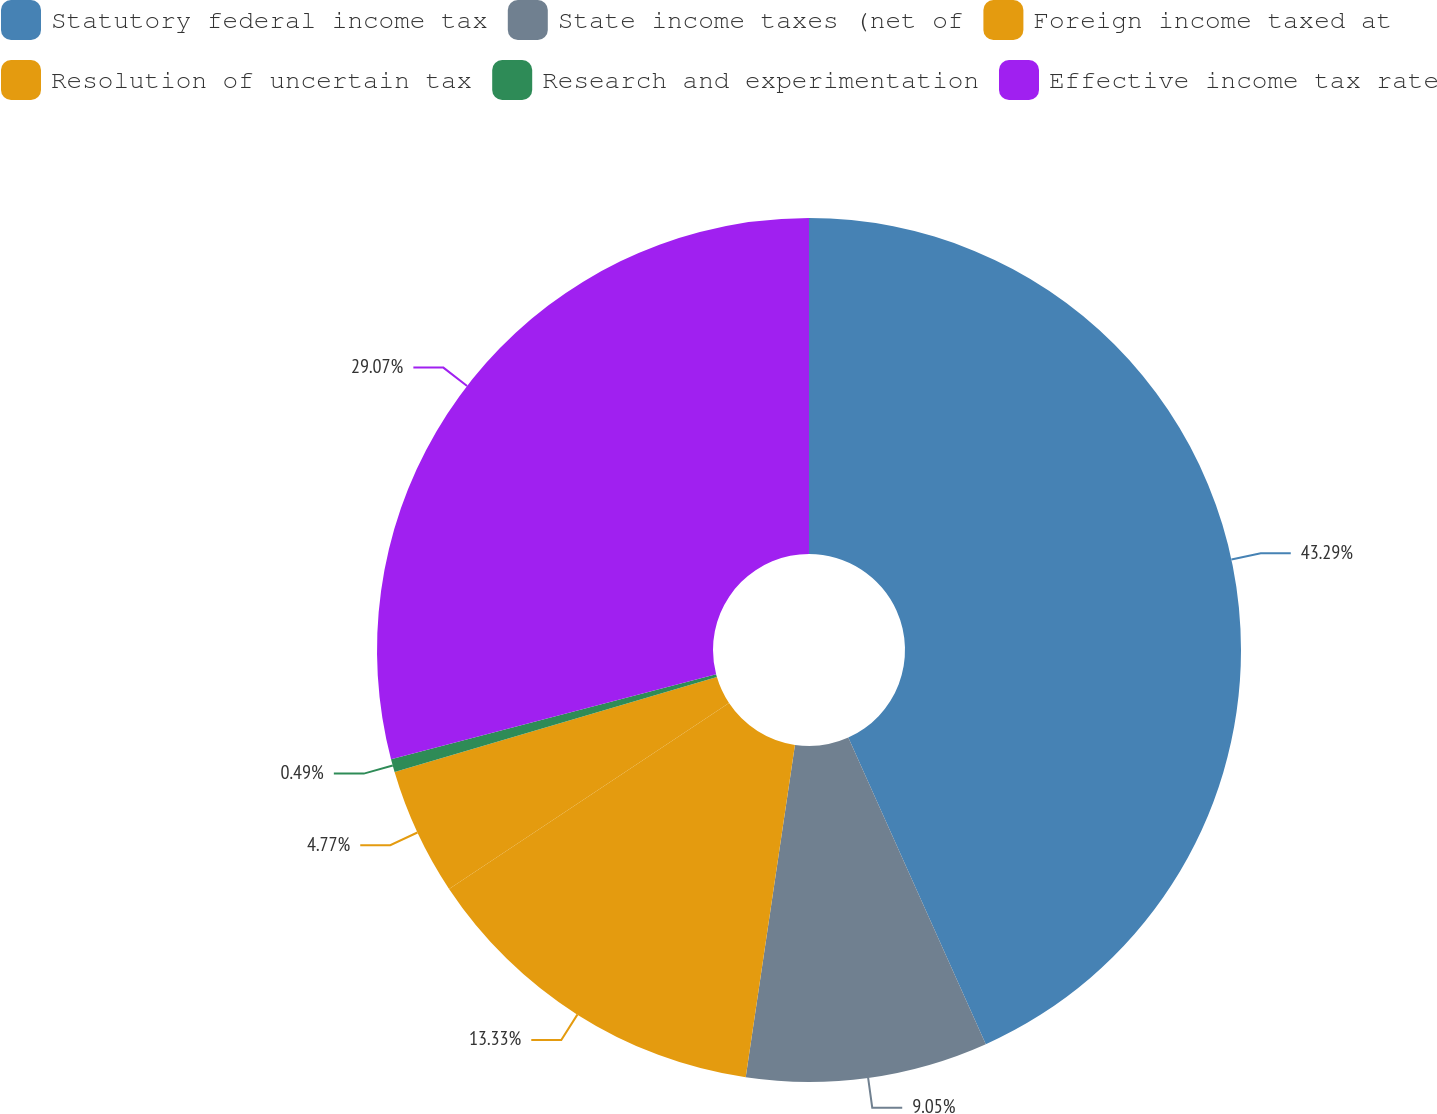Convert chart to OTSL. <chart><loc_0><loc_0><loc_500><loc_500><pie_chart><fcel>Statutory federal income tax<fcel>State income taxes (net of<fcel>Foreign income taxed at<fcel>Resolution of uncertain tax<fcel>Research and experimentation<fcel>Effective income tax rate<nl><fcel>43.28%<fcel>9.05%<fcel>13.33%<fcel>4.77%<fcel>0.49%<fcel>29.06%<nl></chart> 